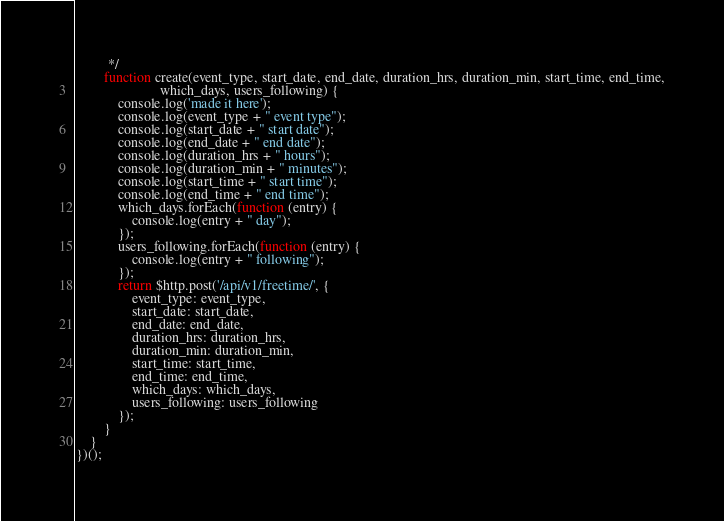Convert code to text. <code><loc_0><loc_0><loc_500><loc_500><_JavaScript_>         */
        function create(event_type, start_date, end_date, duration_hrs, duration_min, start_time, end_time,
                        which_days, users_following) {
            console.log('made it here');
            console.log(event_type + " event type");
            console.log(start_date + " start date");
            console.log(end_date + " end date");
            console.log(duration_hrs + " hours");
            console.log(duration_min + " minutes");
            console.log(start_time + " start time");
            console.log(end_time + " end time");
            which_days.forEach(function (entry) {
                console.log(entry + " day");
            });
            users_following.forEach(function (entry) {
                console.log(entry + " following");
            });
            return $http.post('/api/v1/freetime/', {
                event_type: event_type,
                start_date: start_date,
                end_date: end_date,
                duration_hrs: duration_hrs,
                duration_min: duration_min,
                start_time: start_time,
                end_time: end_time,
                which_days: which_days,
                users_following: users_following
            });
        }
    }
})();
</code> 